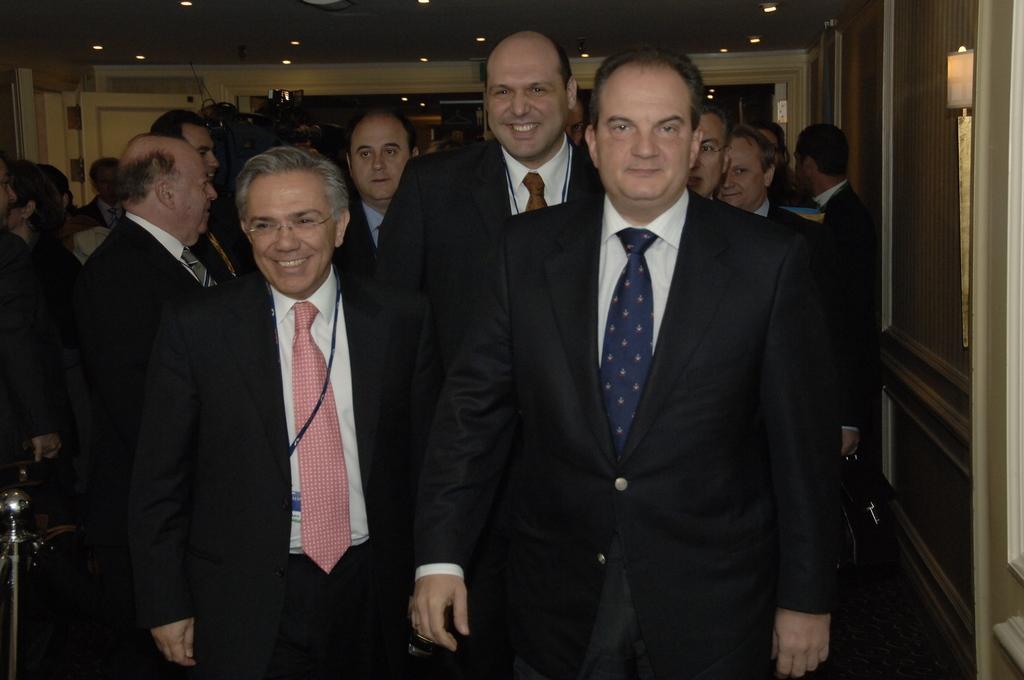Please provide a concise description of this image. In this image there are people standing wearing suits, on the right side there is a wall at top there is ceiling and lights. 